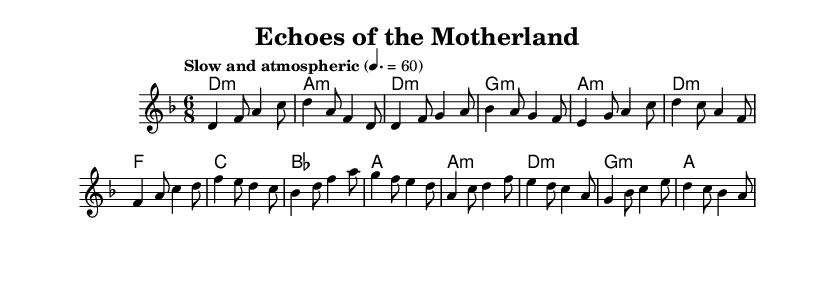What is the key signature of this music? The key signature indicated at the beginning of the music is D minor. This is determined by looking at the key signature signs that appear after the clef, which shows one flat (B♭), characteristic of D minor.
Answer: D minor What is the time signature of this music? The time signature written at the beginning is 6/8, indicating a compound duple meter with six eighth notes in each measure. This is visually evident as the number "6" is placed above the "8" in the signature marking.
Answer: 6/8 What is the tempo marking of this piece? The tempo marking located at the start states "Slow and atmospheric," which suggests a relaxed and spacious feel to the performance. This guides the performer on how to interpret the piece regarding speed and mood.
Answer: Slow and atmospheric How many measures are there in the chorus section? By examining the score, the chorus section consists of four measures, as seen in the group of music notes separated by bar lines that divides each corresponding segment of the melody.
Answer: Four What are the first two chords of the intro? The introductory chords indicated in the part labeled "harmonies" show the first two chords as D minor and A minor. To find this, one simply reads the first two chord markings that appear in the chord section.
Answer: D minor, A minor Which type of musical influences can be identified in this fusion? The fusion reflects a combination of experimental ambient soundscapes with traditional folk melodies by using field recordings and integrating them throughout the structure. This conclusion is drawn from understanding the piece's thematic elements.
Answer: Experimental ambient and folk What emotional atmosphere does the bridge evoke in this piece? The bridge section, marked by specific musical lines and transitions, creates a contemplative and introspective atmosphere due to the slow tempo and minor harmonies, which typically evoke feelings of longing or nostalgia. Observing the dynamics and phrasing also supports this emotional interpretation.
Answer: Contemplative and introspective 